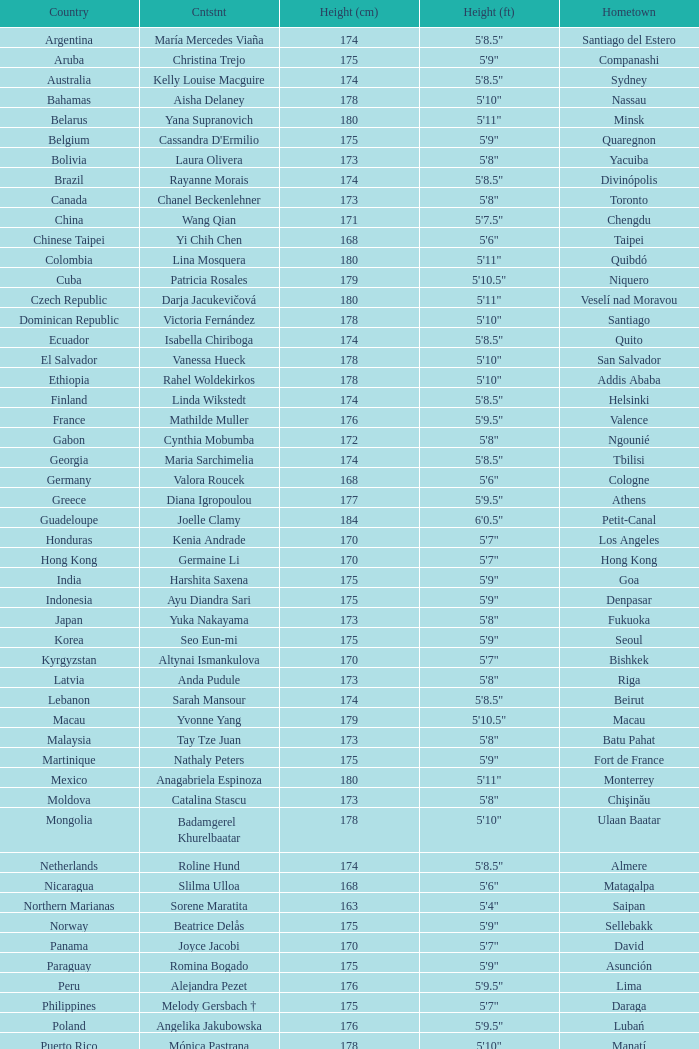What is Cynthia Mobumba's height? 5'8". 